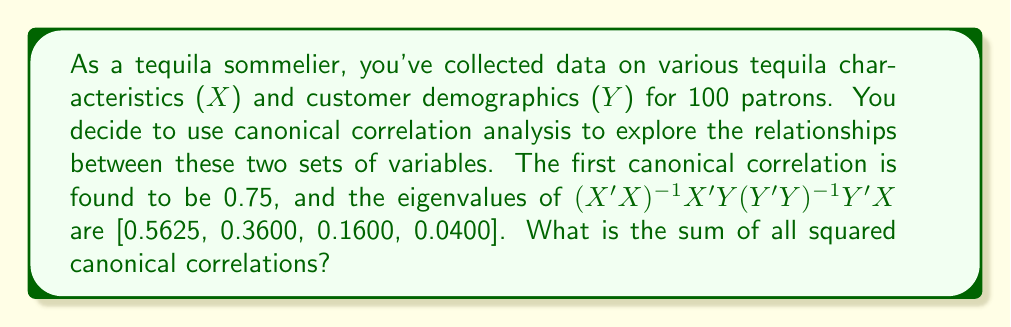Show me your answer to this math problem. To solve this problem, we need to understand the relationship between canonical correlations and the eigenvalues of the matrix $(X'X)^{-1}X'Y(Y'Y)^{-1}Y'X$.

1. In canonical correlation analysis, the squared canonical correlations are equal to the eigenvalues of the matrix $(X'X)^{-1}X'Y(Y'Y)^{-1}Y'X$.

2. We are given that the first canonical correlation is 0.75. Let's verify this:
   $r_1^2 = 0.75^2 = 0.5625$, which matches the first eigenvalue.

3. The sum of all squared canonical correlations is equal to the sum of all eigenvalues of the given matrix.

4. We can calculate this sum as follows:
   $$\sum_{i=1}^{4} r_i^2 = 0.5625 + 0.3600 + 0.1600 + 0.0400$$

5. Performing the addition:
   $$\sum_{i=1}^{4} r_i^2 = 1.1225$$

This sum represents the total amount of shared variance between the two sets of variables (tequila characteristics and customer demographics) that is captured by the canonical variates.
Answer: 1.1225 